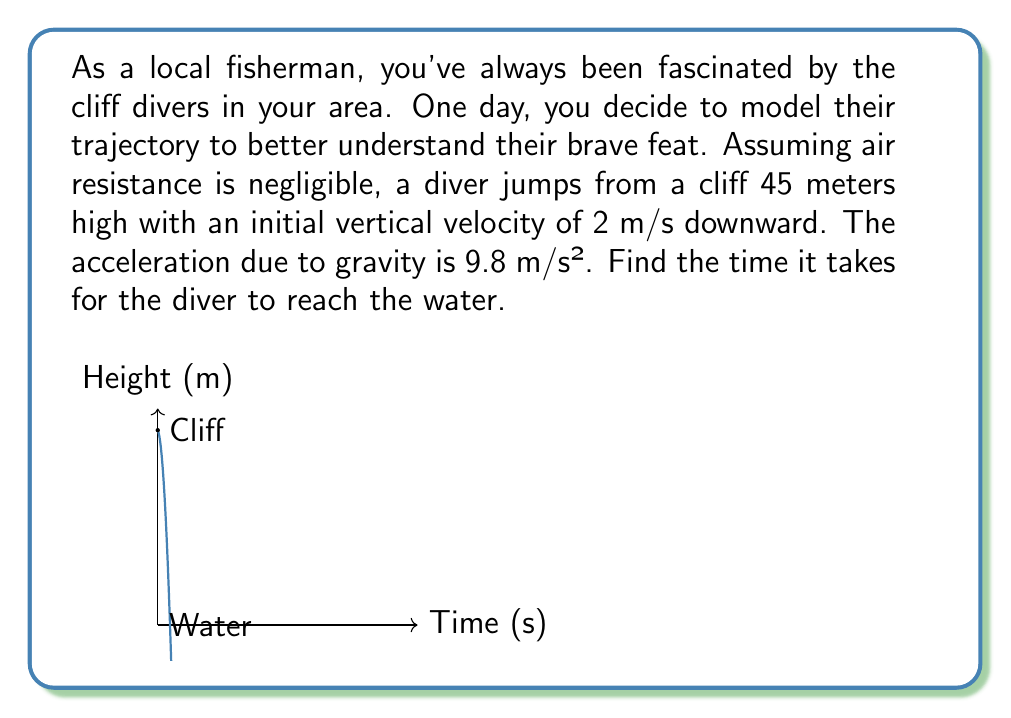Can you solve this math problem? Let's approach this step-by-step:

1) We can model the diver's position using a second-order differential equation. Let $y(t)$ be the diver's height at time $t$.

2) The equation of motion is:

   $$\frac{d^2y}{dt^2} = -g$$

   where $g = 9.8$ m/s² is the acceleration due to gravity.

3) Integrating once:

   $$\frac{dy}{dt} = -gt + v_0$$

   where $v_0$ is the initial velocity. We're given that $v_0 = -2$ m/s (negative because it's downward).

4) Integrating again:

   $$y = -\frac{1}{2}gt^2 + v_0t + y_0$$

   where $y_0$ is the initial height, which is 45 m.

5) Substituting the values:

   $$y = -4.9t^2 - 2t + 45$$

6) We want to find when the diver reaches the water, which is when $y = 0$:

   $$0 = -4.9t^2 - 2t + 45$$

7) This is a quadratic equation. We can solve it using the quadratic formula:

   $$t = \frac{-b \pm \sqrt{b^2 - 4ac}}{2a}$$

   where $a = -4.9$, $b = -2$, and $c = 45$

8) Calculating:

   $$t = \frac{2 \pm \sqrt{4 - 4(-4.9)(45)}}{2(-4.9)} = \frac{2 \pm \sqrt{884}}{-9.8}$$

9) This gives us two solutions: $t ≈ 3.37$ s and $t ≈ -2.96$ s

10) Since time can't be negative in this context, we take the positive solution.

Therefore, it takes approximately 3.37 seconds for the diver to reach the water.
Answer: 3.37 seconds 